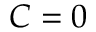<formula> <loc_0><loc_0><loc_500><loc_500>C = 0</formula> 